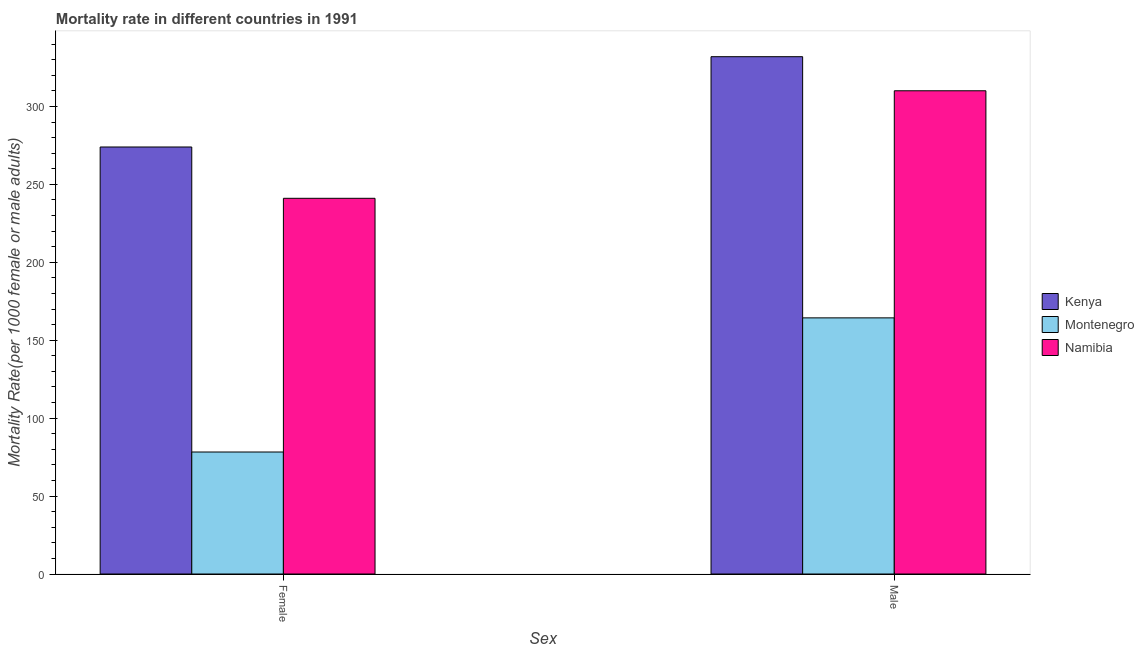How many groups of bars are there?
Offer a terse response. 2. Are the number of bars on each tick of the X-axis equal?
Your response must be concise. Yes. What is the female mortality rate in Montenegro?
Your answer should be very brief. 78.28. Across all countries, what is the maximum female mortality rate?
Your answer should be compact. 273.99. Across all countries, what is the minimum female mortality rate?
Your response must be concise. 78.28. In which country was the female mortality rate maximum?
Provide a succinct answer. Kenya. In which country was the female mortality rate minimum?
Your answer should be very brief. Montenegro. What is the total female mortality rate in the graph?
Make the answer very short. 593.33. What is the difference between the female mortality rate in Montenegro and that in Namibia?
Make the answer very short. -162.78. What is the difference between the female mortality rate in Kenya and the male mortality rate in Montenegro?
Give a very brief answer. 109.65. What is the average female mortality rate per country?
Offer a terse response. 197.78. What is the difference between the female mortality rate and male mortality rate in Namibia?
Your response must be concise. -69. In how many countries, is the female mortality rate greater than 50 ?
Provide a succinct answer. 3. What is the ratio of the female mortality rate in Montenegro to that in Namibia?
Ensure brevity in your answer.  0.32. Is the male mortality rate in Namibia less than that in Kenya?
Provide a succinct answer. Yes. What does the 2nd bar from the left in Female represents?
Offer a terse response. Montenegro. What does the 1st bar from the right in Female represents?
Keep it short and to the point. Namibia. How many bars are there?
Provide a short and direct response. 6. How many countries are there in the graph?
Make the answer very short. 3. Are the values on the major ticks of Y-axis written in scientific E-notation?
Make the answer very short. No. Where does the legend appear in the graph?
Your response must be concise. Center right. How many legend labels are there?
Provide a succinct answer. 3. How are the legend labels stacked?
Provide a succinct answer. Vertical. What is the title of the graph?
Your answer should be very brief. Mortality rate in different countries in 1991. Does "High income: OECD" appear as one of the legend labels in the graph?
Ensure brevity in your answer.  No. What is the label or title of the X-axis?
Keep it short and to the point. Sex. What is the label or title of the Y-axis?
Give a very brief answer. Mortality Rate(per 1000 female or male adults). What is the Mortality Rate(per 1000 female or male adults) of Kenya in Female?
Your response must be concise. 273.99. What is the Mortality Rate(per 1000 female or male adults) of Montenegro in Female?
Give a very brief answer. 78.28. What is the Mortality Rate(per 1000 female or male adults) in Namibia in Female?
Make the answer very short. 241.06. What is the Mortality Rate(per 1000 female or male adults) in Kenya in Male?
Provide a succinct answer. 331.93. What is the Mortality Rate(per 1000 female or male adults) of Montenegro in Male?
Give a very brief answer. 164.35. What is the Mortality Rate(per 1000 female or male adults) of Namibia in Male?
Offer a very short reply. 310.06. Across all Sex, what is the maximum Mortality Rate(per 1000 female or male adults) of Kenya?
Provide a succinct answer. 331.93. Across all Sex, what is the maximum Mortality Rate(per 1000 female or male adults) in Montenegro?
Your answer should be very brief. 164.35. Across all Sex, what is the maximum Mortality Rate(per 1000 female or male adults) in Namibia?
Keep it short and to the point. 310.06. Across all Sex, what is the minimum Mortality Rate(per 1000 female or male adults) in Kenya?
Make the answer very short. 273.99. Across all Sex, what is the minimum Mortality Rate(per 1000 female or male adults) of Montenegro?
Keep it short and to the point. 78.28. Across all Sex, what is the minimum Mortality Rate(per 1000 female or male adults) in Namibia?
Make the answer very short. 241.06. What is the total Mortality Rate(per 1000 female or male adults) in Kenya in the graph?
Provide a short and direct response. 605.92. What is the total Mortality Rate(per 1000 female or male adults) in Montenegro in the graph?
Your response must be concise. 242.63. What is the total Mortality Rate(per 1000 female or male adults) in Namibia in the graph?
Your answer should be very brief. 551.12. What is the difference between the Mortality Rate(per 1000 female or male adults) of Kenya in Female and that in Male?
Provide a short and direct response. -57.94. What is the difference between the Mortality Rate(per 1000 female or male adults) of Montenegro in Female and that in Male?
Your answer should be very brief. -86.07. What is the difference between the Mortality Rate(per 1000 female or male adults) of Namibia in Female and that in Male?
Provide a short and direct response. -69. What is the difference between the Mortality Rate(per 1000 female or male adults) of Kenya in Female and the Mortality Rate(per 1000 female or male adults) of Montenegro in Male?
Offer a terse response. 109.65. What is the difference between the Mortality Rate(per 1000 female or male adults) of Kenya in Female and the Mortality Rate(per 1000 female or male adults) of Namibia in Male?
Provide a succinct answer. -36.07. What is the difference between the Mortality Rate(per 1000 female or male adults) in Montenegro in Female and the Mortality Rate(per 1000 female or male adults) in Namibia in Male?
Your answer should be very brief. -231.78. What is the average Mortality Rate(per 1000 female or male adults) of Kenya per Sex?
Offer a very short reply. 302.96. What is the average Mortality Rate(per 1000 female or male adults) in Montenegro per Sex?
Make the answer very short. 121.31. What is the average Mortality Rate(per 1000 female or male adults) of Namibia per Sex?
Offer a very short reply. 275.56. What is the difference between the Mortality Rate(per 1000 female or male adults) of Kenya and Mortality Rate(per 1000 female or male adults) of Montenegro in Female?
Your answer should be very brief. 195.71. What is the difference between the Mortality Rate(per 1000 female or male adults) of Kenya and Mortality Rate(per 1000 female or male adults) of Namibia in Female?
Make the answer very short. 32.93. What is the difference between the Mortality Rate(per 1000 female or male adults) in Montenegro and Mortality Rate(per 1000 female or male adults) in Namibia in Female?
Give a very brief answer. -162.78. What is the difference between the Mortality Rate(per 1000 female or male adults) in Kenya and Mortality Rate(per 1000 female or male adults) in Montenegro in Male?
Offer a very short reply. 167.58. What is the difference between the Mortality Rate(per 1000 female or male adults) of Kenya and Mortality Rate(per 1000 female or male adults) of Namibia in Male?
Your answer should be compact. 21.87. What is the difference between the Mortality Rate(per 1000 female or male adults) in Montenegro and Mortality Rate(per 1000 female or male adults) in Namibia in Male?
Your answer should be very brief. -145.72. What is the ratio of the Mortality Rate(per 1000 female or male adults) of Kenya in Female to that in Male?
Your answer should be compact. 0.83. What is the ratio of the Mortality Rate(per 1000 female or male adults) of Montenegro in Female to that in Male?
Ensure brevity in your answer.  0.48. What is the ratio of the Mortality Rate(per 1000 female or male adults) in Namibia in Female to that in Male?
Your response must be concise. 0.78. What is the difference between the highest and the second highest Mortality Rate(per 1000 female or male adults) of Kenya?
Give a very brief answer. 57.94. What is the difference between the highest and the second highest Mortality Rate(per 1000 female or male adults) of Montenegro?
Provide a succinct answer. 86.07. What is the difference between the highest and the second highest Mortality Rate(per 1000 female or male adults) in Namibia?
Ensure brevity in your answer.  69. What is the difference between the highest and the lowest Mortality Rate(per 1000 female or male adults) in Kenya?
Offer a very short reply. 57.94. What is the difference between the highest and the lowest Mortality Rate(per 1000 female or male adults) in Montenegro?
Provide a short and direct response. 86.07. What is the difference between the highest and the lowest Mortality Rate(per 1000 female or male adults) in Namibia?
Keep it short and to the point. 69. 